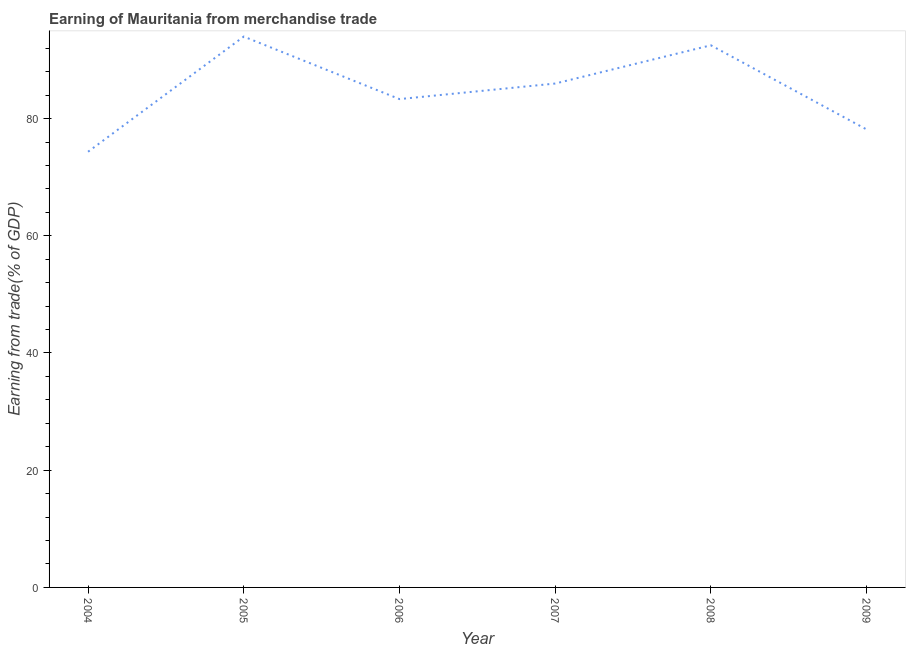What is the earning from merchandise trade in 2004?
Offer a very short reply. 74.34. Across all years, what is the maximum earning from merchandise trade?
Your answer should be very brief. 93.99. Across all years, what is the minimum earning from merchandise trade?
Make the answer very short. 74.34. In which year was the earning from merchandise trade maximum?
Provide a succinct answer. 2005. In which year was the earning from merchandise trade minimum?
Offer a terse response. 2004. What is the sum of the earning from merchandise trade?
Your answer should be very brief. 508.27. What is the difference between the earning from merchandise trade in 2004 and 2009?
Give a very brief answer. -3.81. What is the average earning from merchandise trade per year?
Your answer should be very brief. 84.71. What is the median earning from merchandise trade?
Offer a very short reply. 84.65. Do a majority of the years between 2007 and 2008 (inclusive) have earning from merchandise trade greater than 16 %?
Offer a very short reply. Yes. What is the ratio of the earning from merchandise trade in 2005 to that in 2008?
Keep it short and to the point. 1.02. What is the difference between the highest and the second highest earning from merchandise trade?
Offer a very short reply. 1.49. Is the sum of the earning from merchandise trade in 2006 and 2009 greater than the maximum earning from merchandise trade across all years?
Provide a succinct answer. Yes. What is the difference between the highest and the lowest earning from merchandise trade?
Your answer should be very brief. 19.65. In how many years, is the earning from merchandise trade greater than the average earning from merchandise trade taken over all years?
Make the answer very short. 3. Are the values on the major ticks of Y-axis written in scientific E-notation?
Ensure brevity in your answer.  No. Does the graph contain any zero values?
Offer a terse response. No. What is the title of the graph?
Make the answer very short. Earning of Mauritania from merchandise trade. What is the label or title of the Y-axis?
Offer a very short reply. Earning from trade(% of GDP). What is the Earning from trade(% of GDP) in 2004?
Your answer should be compact. 74.34. What is the Earning from trade(% of GDP) in 2005?
Your answer should be very brief. 93.99. What is the Earning from trade(% of GDP) of 2006?
Give a very brief answer. 83.32. What is the Earning from trade(% of GDP) in 2007?
Give a very brief answer. 85.98. What is the Earning from trade(% of GDP) of 2008?
Your answer should be very brief. 92.5. What is the Earning from trade(% of GDP) in 2009?
Your response must be concise. 78.15. What is the difference between the Earning from trade(% of GDP) in 2004 and 2005?
Give a very brief answer. -19.65. What is the difference between the Earning from trade(% of GDP) in 2004 and 2006?
Offer a very short reply. -8.98. What is the difference between the Earning from trade(% of GDP) in 2004 and 2007?
Ensure brevity in your answer.  -11.64. What is the difference between the Earning from trade(% of GDP) in 2004 and 2008?
Your answer should be compact. -18.16. What is the difference between the Earning from trade(% of GDP) in 2004 and 2009?
Your response must be concise. -3.81. What is the difference between the Earning from trade(% of GDP) in 2005 and 2006?
Provide a succinct answer. 10.67. What is the difference between the Earning from trade(% of GDP) in 2005 and 2007?
Your answer should be compact. 8.01. What is the difference between the Earning from trade(% of GDP) in 2005 and 2008?
Offer a very short reply. 1.49. What is the difference between the Earning from trade(% of GDP) in 2005 and 2009?
Offer a very short reply. 15.84. What is the difference between the Earning from trade(% of GDP) in 2006 and 2007?
Give a very brief answer. -2.65. What is the difference between the Earning from trade(% of GDP) in 2006 and 2008?
Give a very brief answer. -9.18. What is the difference between the Earning from trade(% of GDP) in 2006 and 2009?
Offer a very short reply. 5.18. What is the difference between the Earning from trade(% of GDP) in 2007 and 2008?
Give a very brief answer. -6.53. What is the difference between the Earning from trade(% of GDP) in 2007 and 2009?
Give a very brief answer. 7.83. What is the difference between the Earning from trade(% of GDP) in 2008 and 2009?
Provide a succinct answer. 14.36. What is the ratio of the Earning from trade(% of GDP) in 2004 to that in 2005?
Give a very brief answer. 0.79. What is the ratio of the Earning from trade(% of GDP) in 2004 to that in 2006?
Provide a succinct answer. 0.89. What is the ratio of the Earning from trade(% of GDP) in 2004 to that in 2007?
Provide a succinct answer. 0.86. What is the ratio of the Earning from trade(% of GDP) in 2004 to that in 2008?
Your answer should be compact. 0.8. What is the ratio of the Earning from trade(% of GDP) in 2004 to that in 2009?
Your answer should be compact. 0.95. What is the ratio of the Earning from trade(% of GDP) in 2005 to that in 2006?
Your answer should be compact. 1.13. What is the ratio of the Earning from trade(% of GDP) in 2005 to that in 2007?
Keep it short and to the point. 1.09. What is the ratio of the Earning from trade(% of GDP) in 2005 to that in 2009?
Ensure brevity in your answer.  1.2. What is the ratio of the Earning from trade(% of GDP) in 2006 to that in 2007?
Provide a succinct answer. 0.97. What is the ratio of the Earning from trade(% of GDP) in 2006 to that in 2008?
Your response must be concise. 0.9. What is the ratio of the Earning from trade(% of GDP) in 2006 to that in 2009?
Keep it short and to the point. 1.07. What is the ratio of the Earning from trade(% of GDP) in 2007 to that in 2008?
Give a very brief answer. 0.93. What is the ratio of the Earning from trade(% of GDP) in 2007 to that in 2009?
Your response must be concise. 1.1. What is the ratio of the Earning from trade(% of GDP) in 2008 to that in 2009?
Your answer should be compact. 1.18. 